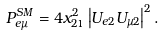Convert formula to latex. <formula><loc_0><loc_0><loc_500><loc_500>P _ { e \mu } ^ { S M } = 4 x _ { 2 1 } ^ { 2 } \left | U _ { e 2 } U _ { \mu 2 } \right | ^ { 2 } .</formula> 